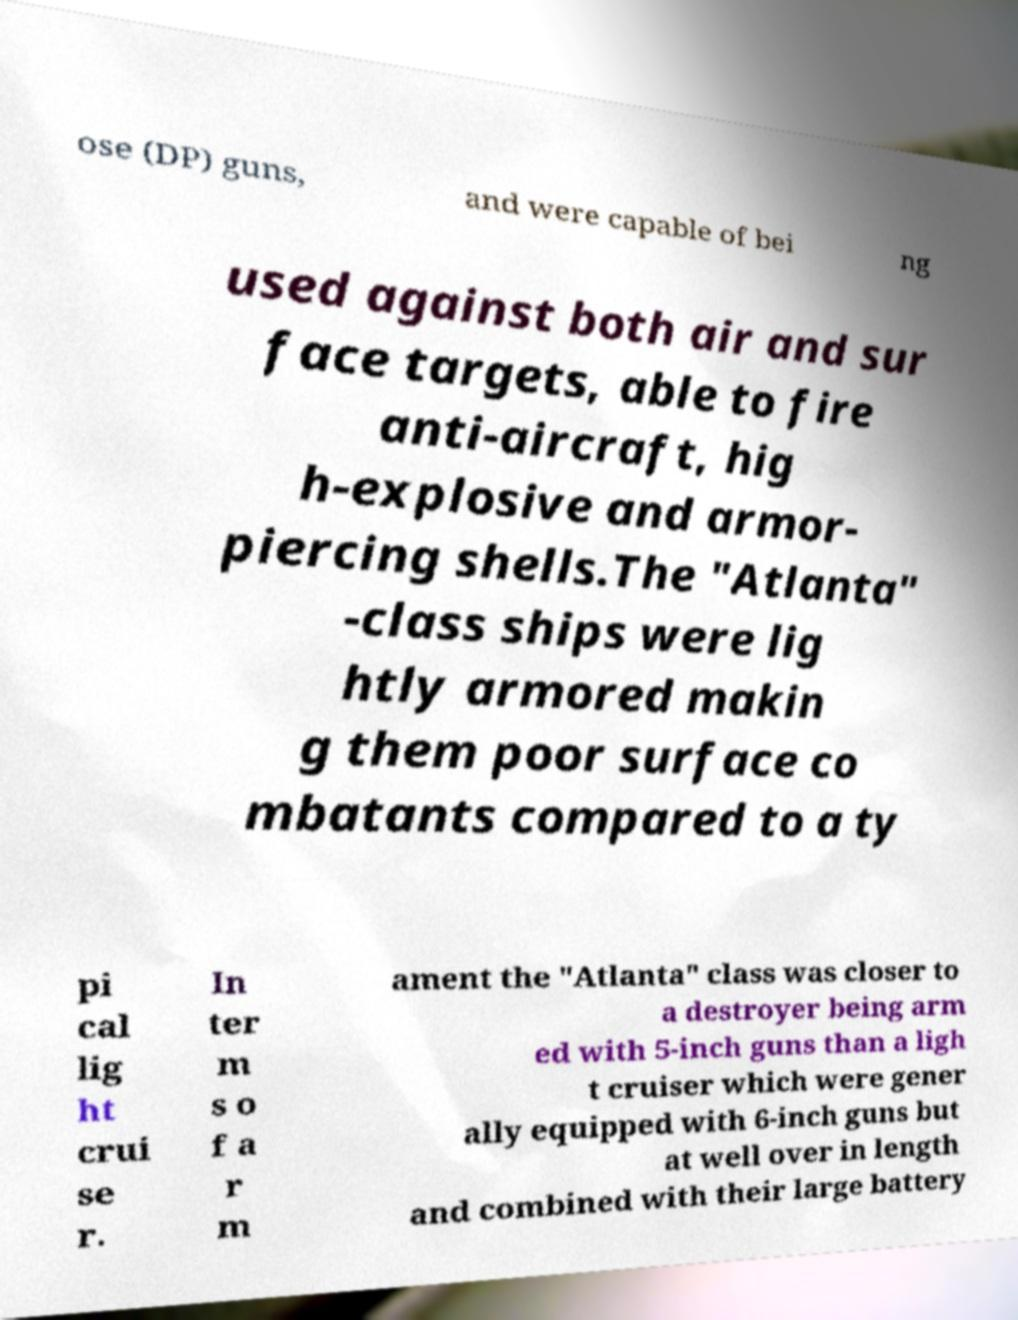Could you assist in decoding the text presented in this image and type it out clearly? ose (DP) guns, and were capable of bei ng used against both air and sur face targets, able to fire anti-aircraft, hig h-explosive and armor- piercing shells.The "Atlanta" -class ships were lig htly armored makin g them poor surface co mbatants compared to a ty pi cal lig ht crui se r. In ter m s o f a r m ament the "Atlanta" class was closer to a destroyer being arm ed with 5-inch guns than a ligh t cruiser which were gener ally equipped with 6-inch guns but at well over in length and combined with their large battery 